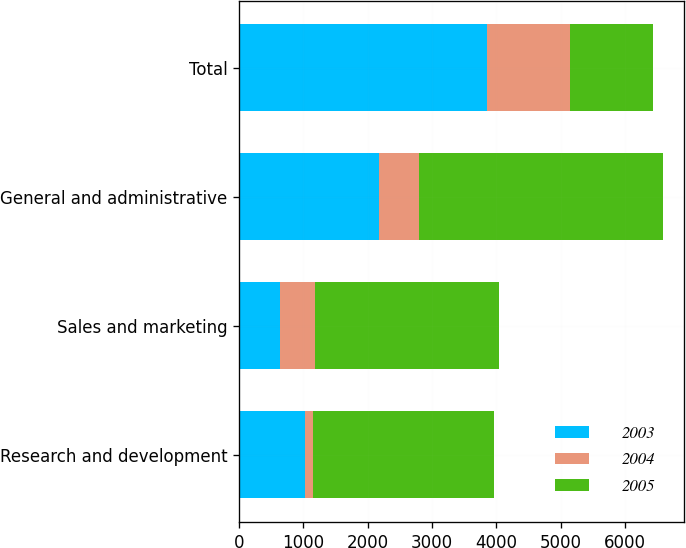<chart> <loc_0><loc_0><loc_500><loc_500><stacked_bar_chart><ecel><fcel>Research and development<fcel>Sales and marketing<fcel>General and administrative<fcel>Total<nl><fcel>2003<fcel>1034<fcel>636<fcel>2179<fcel>3849<nl><fcel>2004<fcel>118<fcel>549<fcel>621<fcel>1292<nl><fcel>2005<fcel>2819<fcel>2852<fcel>3784<fcel>1292<nl></chart> 